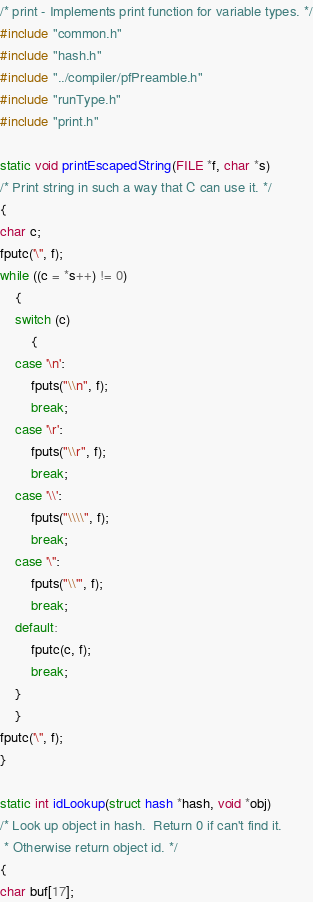<code> <loc_0><loc_0><loc_500><loc_500><_C_>/* print - Implements print function for variable types. */
#include "common.h"
#include "hash.h"
#include "../compiler/pfPreamble.h"
#include "runType.h"
#include "print.h"

static void printEscapedString(FILE *f, char *s)
/* Print string in such a way that C can use it. */
{
char c;
fputc('\'', f);
while ((c = *s++) != 0)
    {
    switch (c)
        {
	case '\n':
	    fputs("\\n", f);
	    break;
	case '\r':
	    fputs("\\r", f);
	    break;
	case '\\':
	    fputs("\\\\", f);
	    break;
	case '\'':
	    fputs("\\'", f);
	    break;
	default:
	    fputc(c, f);
	    break;
	}
    }
fputc('\'', f);
}

static int idLookup(struct hash *hash, void *obj)
/* Look up object in hash.  Return 0 if can't find it.
 * Otherwise return object id. */
{
char buf[17];</code> 